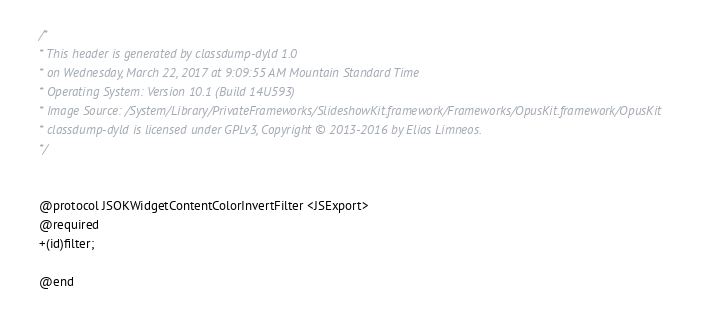<code> <loc_0><loc_0><loc_500><loc_500><_C_>/*
* This header is generated by classdump-dyld 1.0
* on Wednesday, March 22, 2017 at 9:09:55 AM Mountain Standard Time
* Operating System: Version 10.1 (Build 14U593)
* Image Source: /System/Library/PrivateFrameworks/SlideshowKit.framework/Frameworks/OpusKit.framework/OpusKit
* classdump-dyld is licensed under GPLv3, Copyright © 2013-2016 by Elias Limneos.
*/


@protocol JSOKWidgetContentColorInvertFilter <JSExport>
@required
+(id)filter;

@end

</code> 